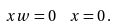<formula> <loc_0><loc_0><loc_500><loc_500>x w = 0 \ \ x = 0 \, .</formula> 